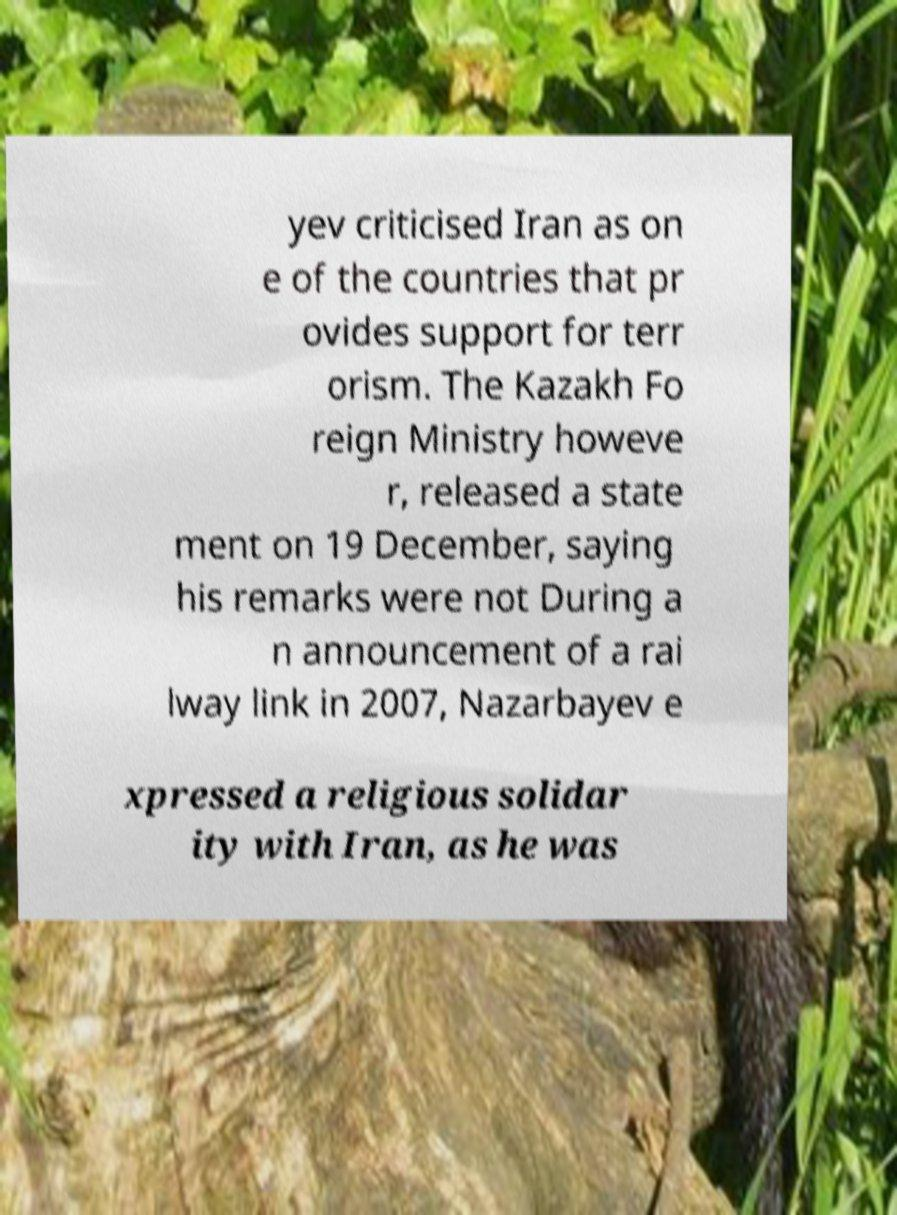There's text embedded in this image that I need extracted. Can you transcribe it verbatim? yev criticised Iran as on e of the countries that pr ovides support for terr orism. The Kazakh Fo reign Ministry howeve r, released a state ment on 19 December, saying his remarks were not During a n announcement of a rai lway link in 2007, Nazarbayev e xpressed a religious solidar ity with Iran, as he was 